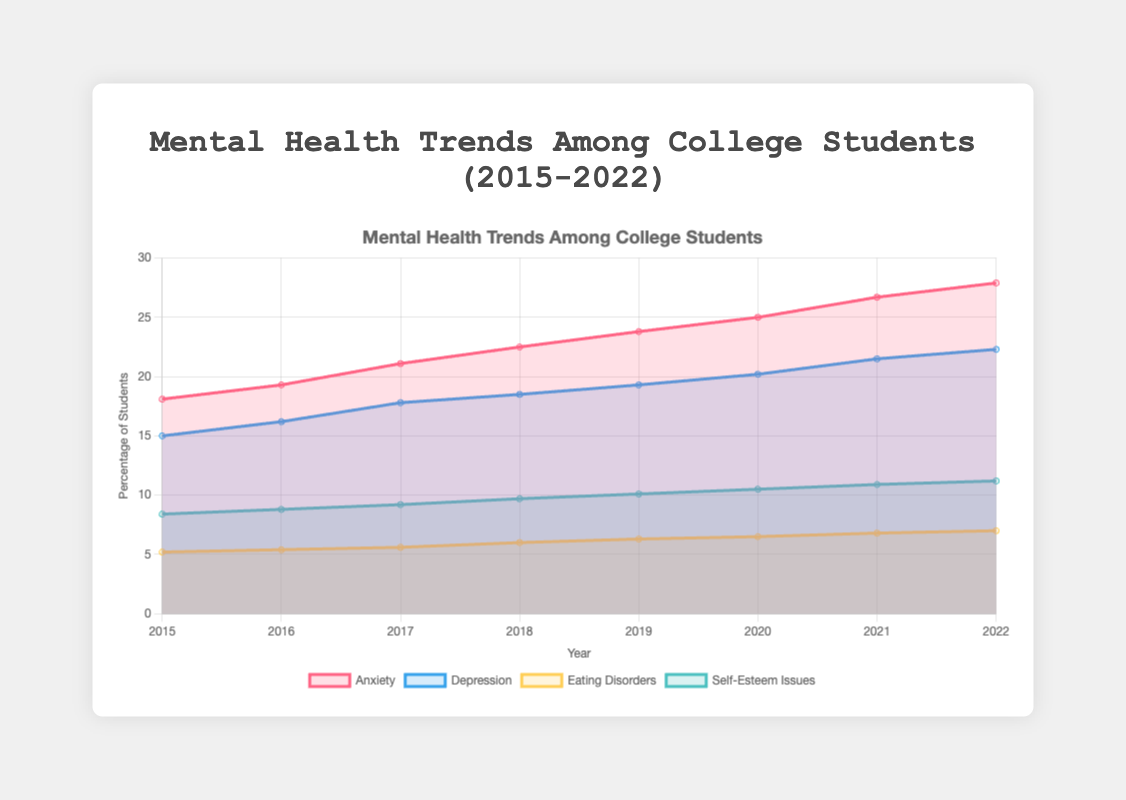What are the four mental health conditions tracked in the chart? The area chart tracks four mental health conditions among college students: anxiety, depression, eating disorders, and self-esteem issues.
Answer: Anxiety, Depression, Eating Disorders, Self-Esteem Issues From 2015 to 2022, which mental health condition shows the highest increase in percentage? Comparing the values from 2015 to 2022, anxiety increased from 18.1% to 27.9%, depression from 15.0% to 22.3%, eating disorders from 5.2% to 7.0%, and self-esteem issues from 8.4% to 11.2%. Anxiety shows the highest increase.
Answer: Anxiety By how much did the percentage of students with depression increase from 2015 to 2022? In 2015, the depression rate was 15.0%, and in 2022 it was 22.3%. The increase can be calculated as 22.3% - 15.0% = 7.3%.
Answer: 7.3% Which year saw the highest percentage of students experiencing self-esteem issues? Looking at the percentages of self-esteem issues over the years, the highest value is in 2022 at 11.2%.
Answer: 2022 On average, what was the percentage of students facing eating disorders between 2015 and 2022? The percentages for eating disorders over the years are 5.2, 5.4, 5.6, 6.0, 6.3, 6.5, 6.8, and 7.0. Adding these values and dividing by the number of years (8) gives (5.2 + 5.4 + 5.6 + 6.0 + 6.3 + 6.5 + 6.8 + 7.0) / 8 = 6.1%.
Answer: 6.1% In which year did anxiety surpass 25% among college students? Checking the anxiety percentages, anxiety surpasses 25% for the first time in 2021, where it reaches 26.7%.
Answer: 2021 Did the percentage of students with depression ever decrease from one year to the next within the given timeframe? Observing the depression percentages, we see a consistent rise from 15.0% in 2015 to 22.3% in 2022 without any decrease.
Answer: No Compare the rate of increase in depression from 2015 to 2018 with the rate of increase from 2018 to 2022. Which period saw a greater increase? From 2015 to 2018, depression increased from 15.0% to 18.5% (an increase of 3.5%). From 2018 to 2022, it increased from 18.5% to 22.3% (an increase of 3.8%). The latter period saw a greater increase.
Answer: 2018 to 2022 Which mental health condition shows the smallest overall change from 2015 to 2022? By comparing the overall increases: anxiety (9.8%), depression (7.3%), eating disorders (1.8%), and self-esteem issues (2.8%), eating disorders show the smallest change.
Answer: Eating Disorders What was the combined percentage of students facing both anxiety and self-esteem issues in 2020? In 2020, anxiety affected 25.0% and self-esteem issues affected 10.5% of students. The combined percentage is 25.0% + 10.5% = 35.5%.
Answer: 35.5% 